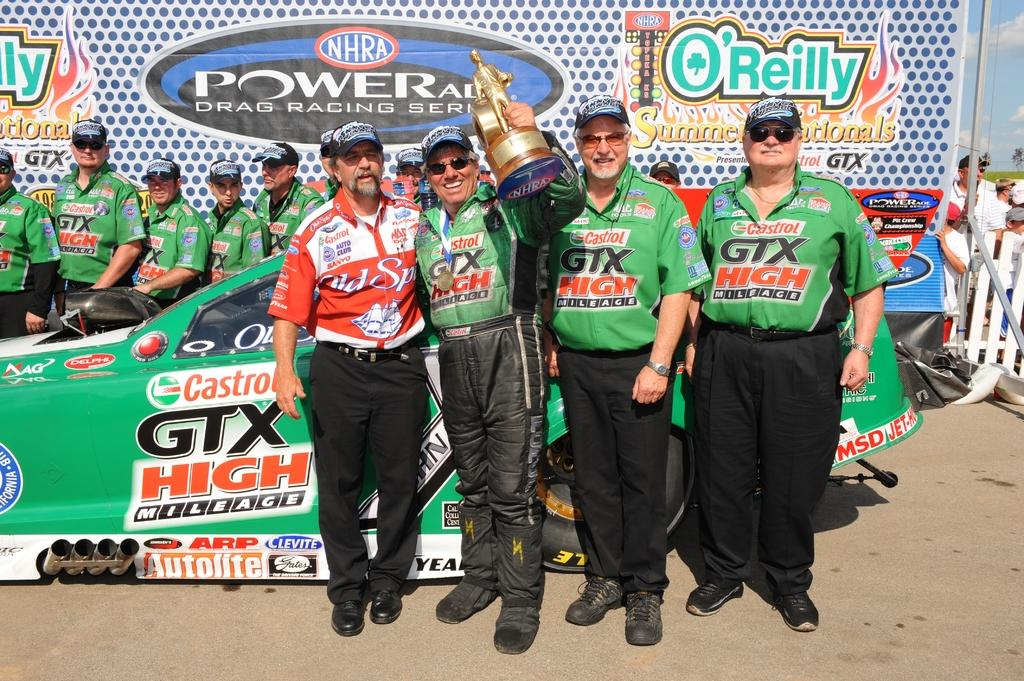Provide a one-sentence caption for the provided image. Members of an NHRA drag race team standing in front of a race car with one member holding up a trophy. 